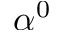Convert formula to latex. <formula><loc_0><loc_0><loc_500><loc_500>\alpha ^ { 0 }</formula> 